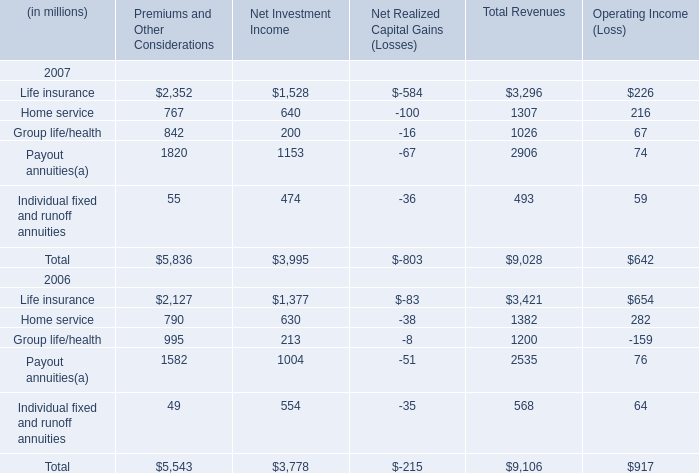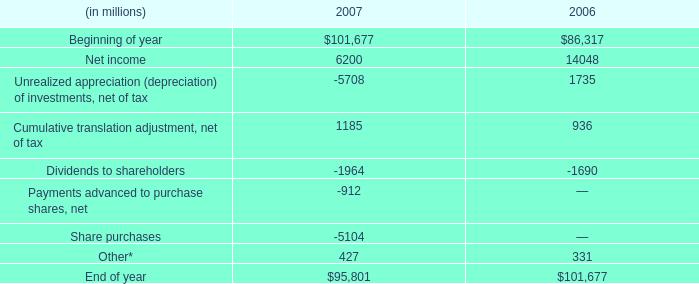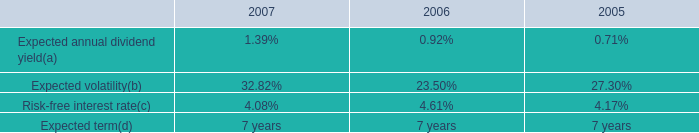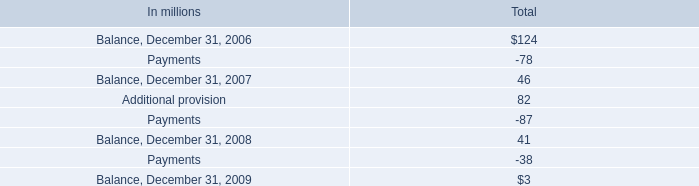What is the sum of Life insurance, Home service and Group life/health in Total Revenues in 2007 ? (in millions) 
Computations: ((3296 + 1307) + 1026)
Answer: 5629.0. 